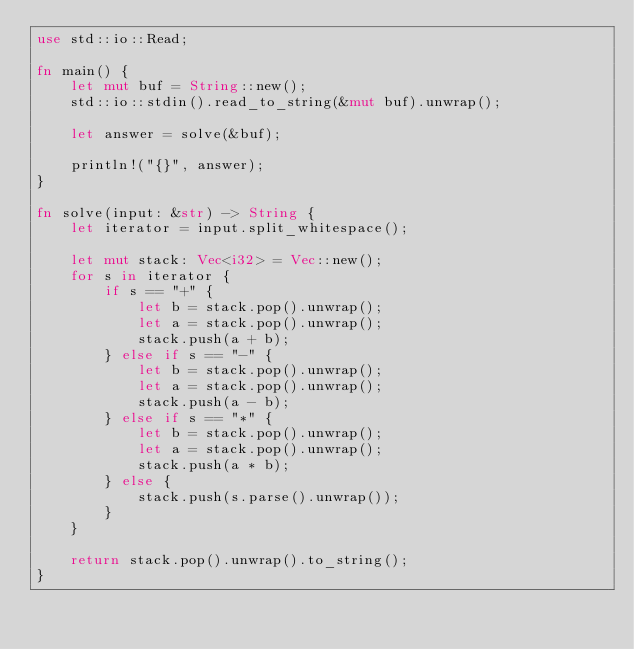Convert code to text. <code><loc_0><loc_0><loc_500><loc_500><_Rust_>use std::io::Read;

fn main() {
    let mut buf = String::new();
    std::io::stdin().read_to_string(&mut buf).unwrap();

    let answer = solve(&buf);

    println!("{}", answer);
}

fn solve(input: &str) -> String {
    let iterator = input.split_whitespace();

    let mut stack: Vec<i32> = Vec::new();
    for s in iterator {
        if s == "+" {
            let b = stack.pop().unwrap();
            let a = stack.pop().unwrap();
            stack.push(a + b);
        } else if s == "-" {
            let b = stack.pop().unwrap();
            let a = stack.pop().unwrap();
            stack.push(a - b);
        } else if s == "*" {
            let b = stack.pop().unwrap();
            let a = stack.pop().unwrap();
            stack.push(a * b);
        } else {
            stack.push(s.parse().unwrap());
        }
    }

    return stack.pop().unwrap().to_string();
}

</code> 